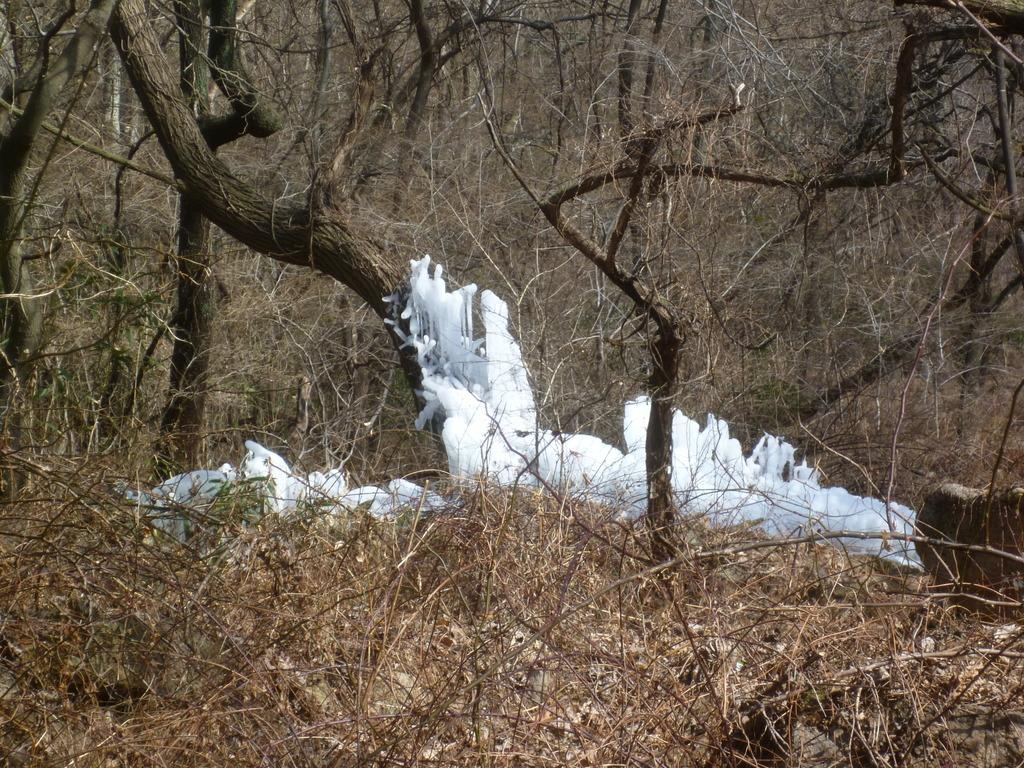What type of environment is depicted in the image? The image is taken in a forest. What is located in the middle of the image? There is ice in the middle of the image. What can be seen in the background of the image? There are trees and dry grass in the background of the image. How many jellyfish can be seen swimming in the ice in the image? There are no jellyfish present in the image; it features a forest setting with ice in the middle. What type of bells are hanging from the trees in the background of the image? There are no bells visible in the image; it only shows trees and dry grass in the background. 